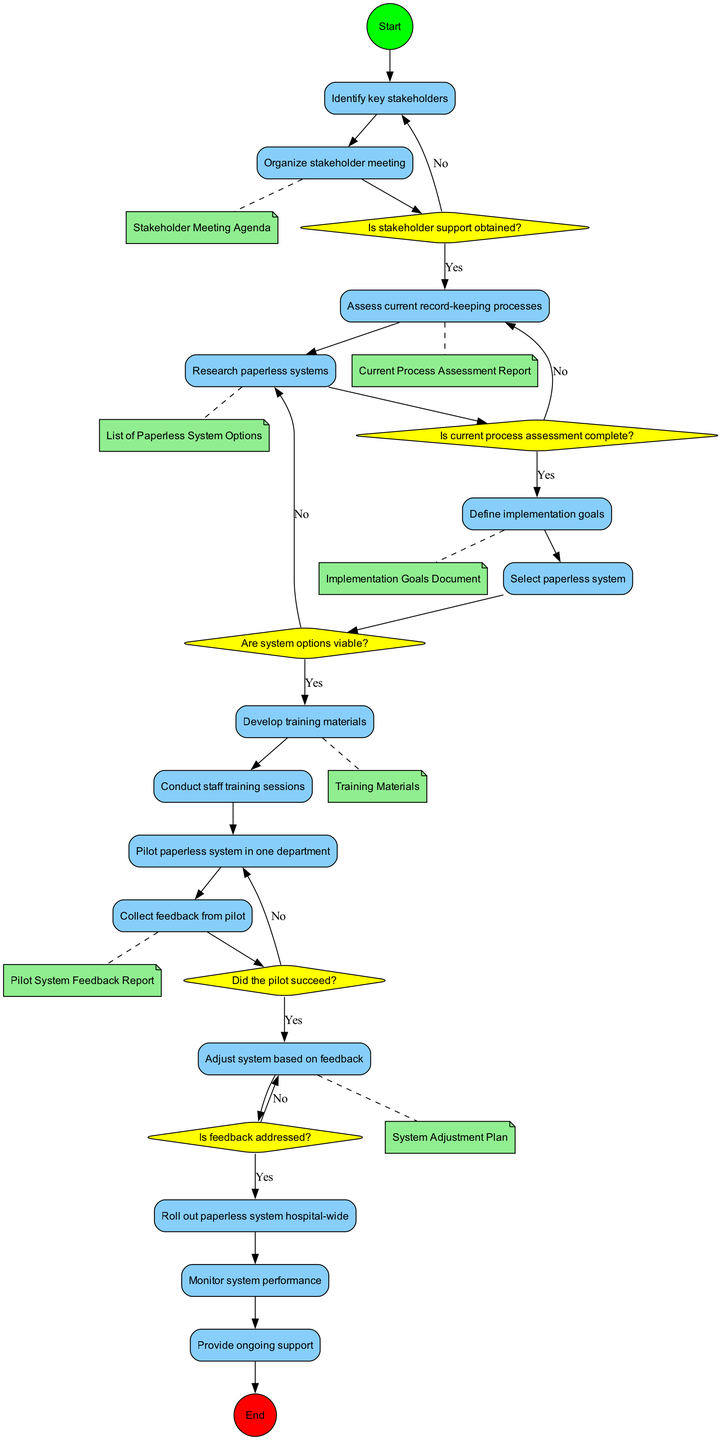What is the first action in the diagram? The diagram starts with the node labeled "Start," which connects to the first action node labeled "Identify key stakeholders."
Answer: Identify key stakeholders Which decision point follows assessing current record-keeping processes? After the action "Assess current record-keeping processes," the next node is the decision point labeled "Is current process assessment complete?"
Answer: Is current process assessment complete? How many actions are in the diagram? The diagram contains a total of 13 actions as listed.
Answer: 13 What is the last action before the end node? The last action that connects to the end node is "Provide ongoing support," which is the action after the systematic rollout and monitoring of the paperless system.
Answer: Provide ongoing support Which object is associated with developing training materials? The object connected to the action "Develop training materials" is the "Training Materials" object, as indicated by a dashed line connection.
Answer: Training Materials What happens if stakeholder support is not obtained? If stakeholder support is not obtained, the flow goes back to the action "Organize stakeholder meeting," indicating a loop back to try and acquire the necessary support.
Answer: Organize stakeholder meeting Did the pilot succeed? The decision point labeled "Did the pilot succeed?" determines if the next step can progress, leading to actions either for adjustments or further actions based on feedback.
Answer: Did the pilot succeed? What type of diagram is this? This diagram is an Activity Diagram, which is designed to describe the flow of activities and decisions in a process.
Answer: Activity Diagram 